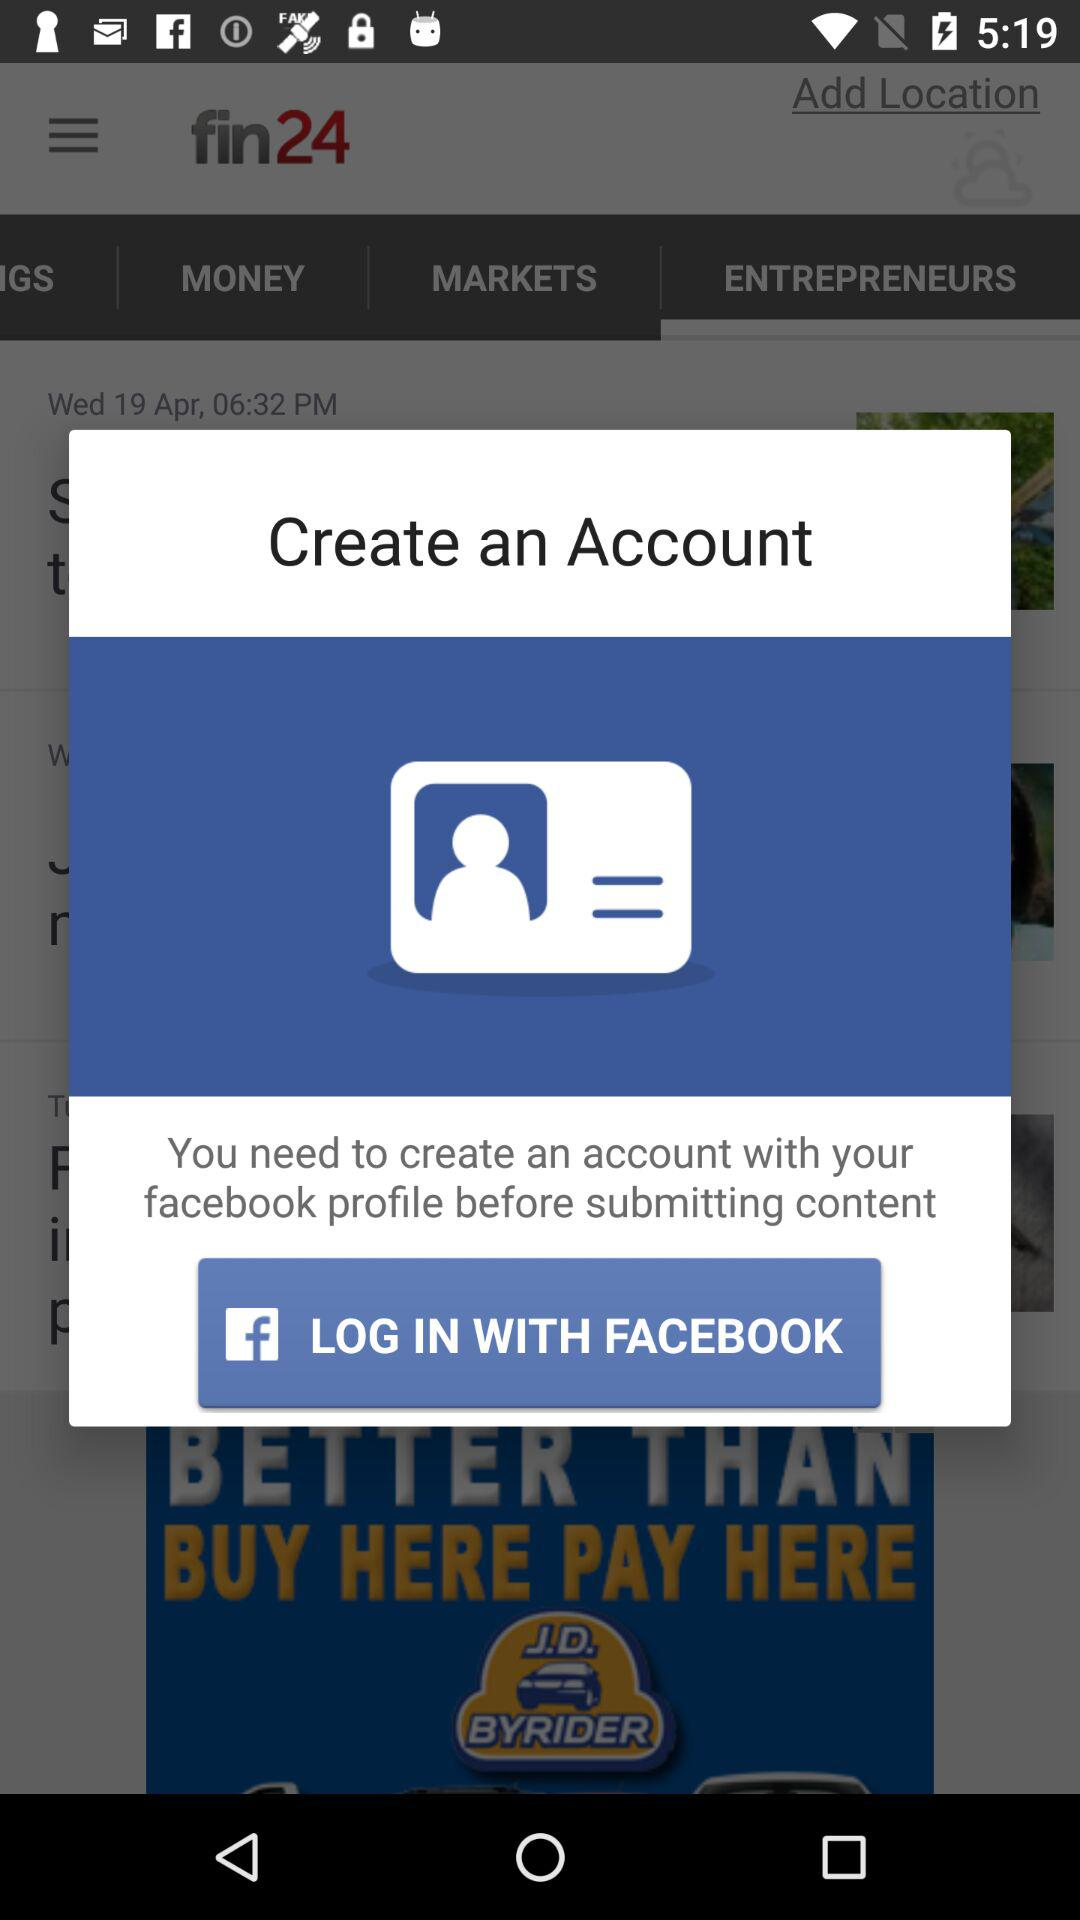What application is used to log in? The application used to log in is "FACEBOOK". 